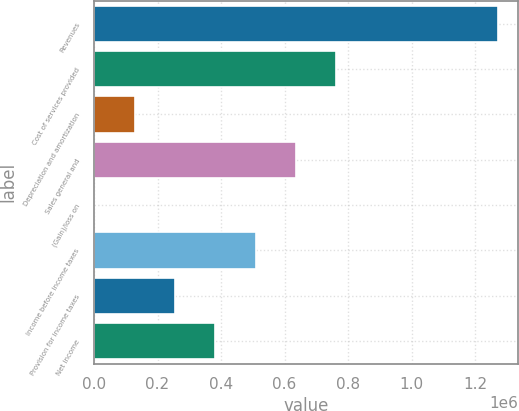<chart> <loc_0><loc_0><loc_500><loc_500><bar_chart><fcel>Revenues<fcel>Cost of services provided<fcel>Depreciation and amortization<fcel>Sales general and<fcel>(Gain)/loss on<fcel>Income before income taxes<fcel>Provision for income taxes<fcel>Net income<nl><fcel>1.27091e+06<fcel>762733<fcel>127512<fcel>635688<fcel>468<fcel>508644<fcel>254556<fcel>381600<nl></chart> 